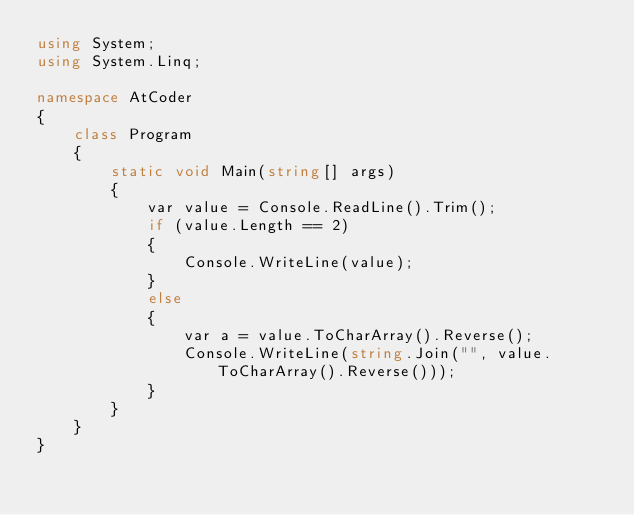<code> <loc_0><loc_0><loc_500><loc_500><_C#_>using System;
using System.Linq;

namespace AtCoder
{
    class Program
    {
        static void Main(string[] args)
        {
            var value = Console.ReadLine().Trim();
            if (value.Length == 2)
            {
                Console.WriteLine(value);
            }
            else
            {
                var a = value.ToCharArray().Reverse();
                Console.WriteLine(string.Join("", value.ToCharArray().Reverse()));
            }
        }
    }
}</code> 